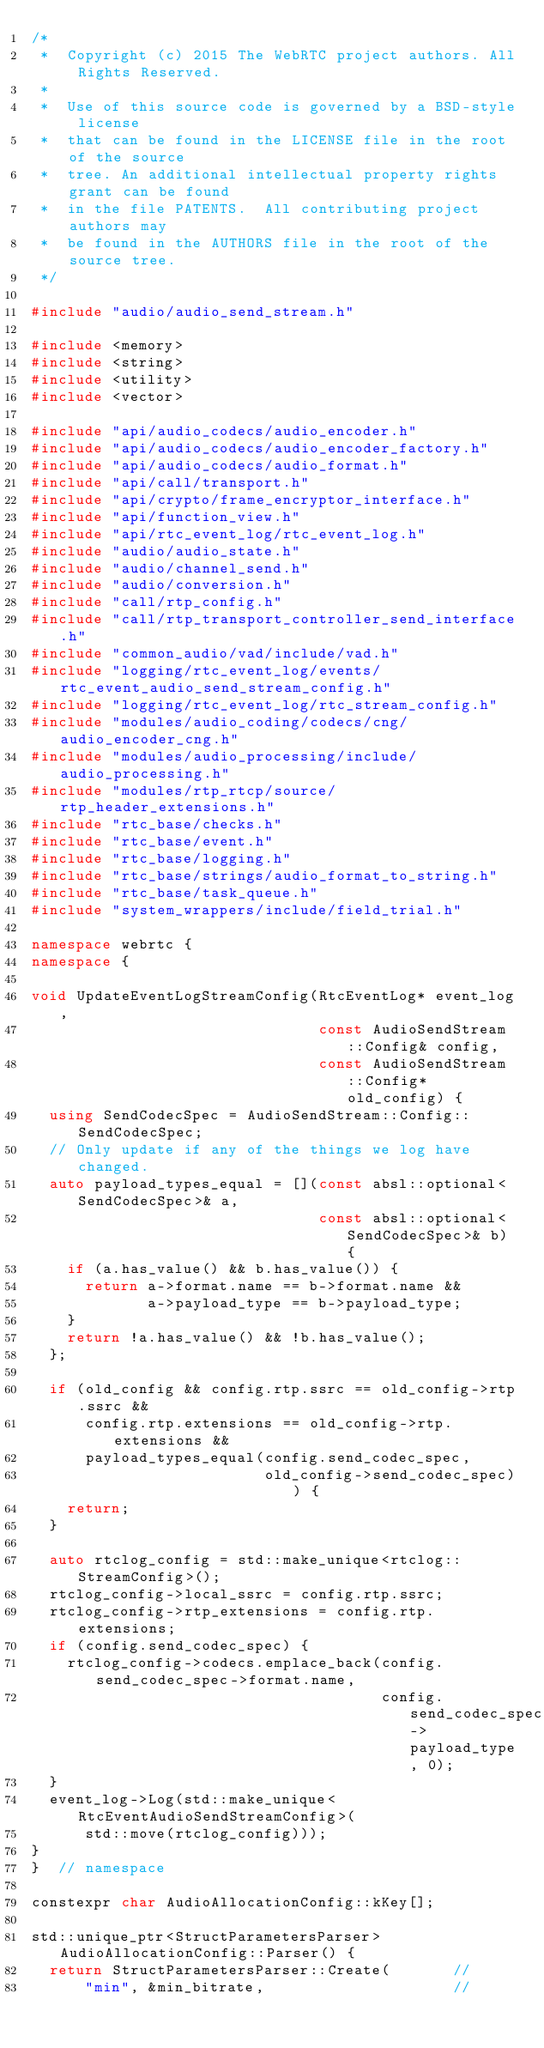<code> <loc_0><loc_0><loc_500><loc_500><_C++_>/*
 *  Copyright (c) 2015 The WebRTC project authors. All Rights Reserved.
 *
 *  Use of this source code is governed by a BSD-style license
 *  that can be found in the LICENSE file in the root of the source
 *  tree. An additional intellectual property rights grant can be found
 *  in the file PATENTS.  All contributing project authors may
 *  be found in the AUTHORS file in the root of the source tree.
 */

#include "audio/audio_send_stream.h"

#include <memory>
#include <string>
#include <utility>
#include <vector>

#include "api/audio_codecs/audio_encoder.h"
#include "api/audio_codecs/audio_encoder_factory.h"
#include "api/audio_codecs/audio_format.h"
#include "api/call/transport.h"
#include "api/crypto/frame_encryptor_interface.h"
#include "api/function_view.h"
#include "api/rtc_event_log/rtc_event_log.h"
#include "audio/audio_state.h"
#include "audio/channel_send.h"
#include "audio/conversion.h"
#include "call/rtp_config.h"
#include "call/rtp_transport_controller_send_interface.h"
#include "common_audio/vad/include/vad.h"
#include "logging/rtc_event_log/events/rtc_event_audio_send_stream_config.h"
#include "logging/rtc_event_log/rtc_stream_config.h"
#include "modules/audio_coding/codecs/cng/audio_encoder_cng.h"
#include "modules/audio_processing/include/audio_processing.h"
#include "modules/rtp_rtcp/source/rtp_header_extensions.h"
#include "rtc_base/checks.h"
#include "rtc_base/event.h"
#include "rtc_base/logging.h"
#include "rtc_base/strings/audio_format_to_string.h"
#include "rtc_base/task_queue.h"
#include "system_wrappers/include/field_trial.h"

namespace webrtc {
namespace {

void UpdateEventLogStreamConfig(RtcEventLog* event_log,
                                const AudioSendStream::Config& config,
                                const AudioSendStream::Config* old_config) {
  using SendCodecSpec = AudioSendStream::Config::SendCodecSpec;
  // Only update if any of the things we log have changed.
  auto payload_types_equal = [](const absl::optional<SendCodecSpec>& a,
                                const absl::optional<SendCodecSpec>& b) {
    if (a.has_value() && b.has_value()) {
      return a->format.name == b->format.name &&
             a->payload_type == b->payload_type;
    }
    return !a.has_value() && !b.has_value();
  };

  if (old_config && config.rtp.ssrc == old_config->rtp.ssrc &&
      config.rtp.extensions == old_config->rtp.extensions &&
      payload_types_equal(config.send_codec_spec,
                          old_config->send_codec_spec)) {
    return;
  }

  auto rtclog_config = std::make_unique<rtclog::StreamConfig>();
  rtclog_config->local_ssrc = config.rtp.ssrc;
  rtclog_config->rtp_extensions = config.rtp.extensions;
  if (config.send_codec_spec) {
    rtclog_config->codecs.emplace_back(config.send_codec_spec->format.name,
                                       config.send_codec_spec->payload_type, 0);
  }
  event_log->Log(std::make_unique<RtcEventAudioSendStreamConfig>(
      std::move(rtclog_config)));
}
}  // namespace

constexpr char AudioAllocationConfig::kKey[];

std::unique_ptr<StructParametersParser> AudioAllocationConfig::Parser() {
  return StructParametersParser::Create(       //
      "min", &min_bitrate,                     //</code> 